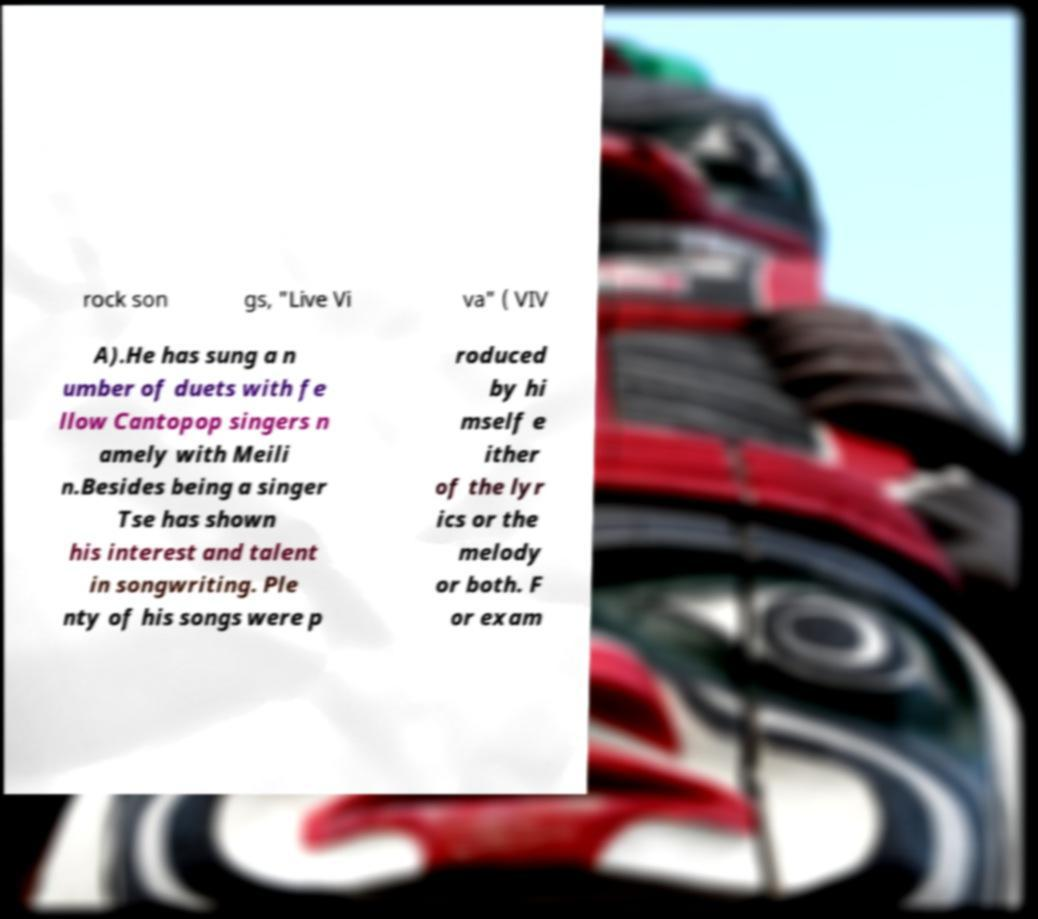For documentation purposes, I need the text within this image transcribed. Could you provide that? rock son gs, "Live Vi va" ( VIV A).He has sung a n umber of duets with fe llow Cantopop singers n amely with Meili n.Besides being a singer Tse has shown his interest and talent in songwriting. Ple nty of his songs were p roduced by hi mself e ither of the lyr ics or the melody or both. F or exam 